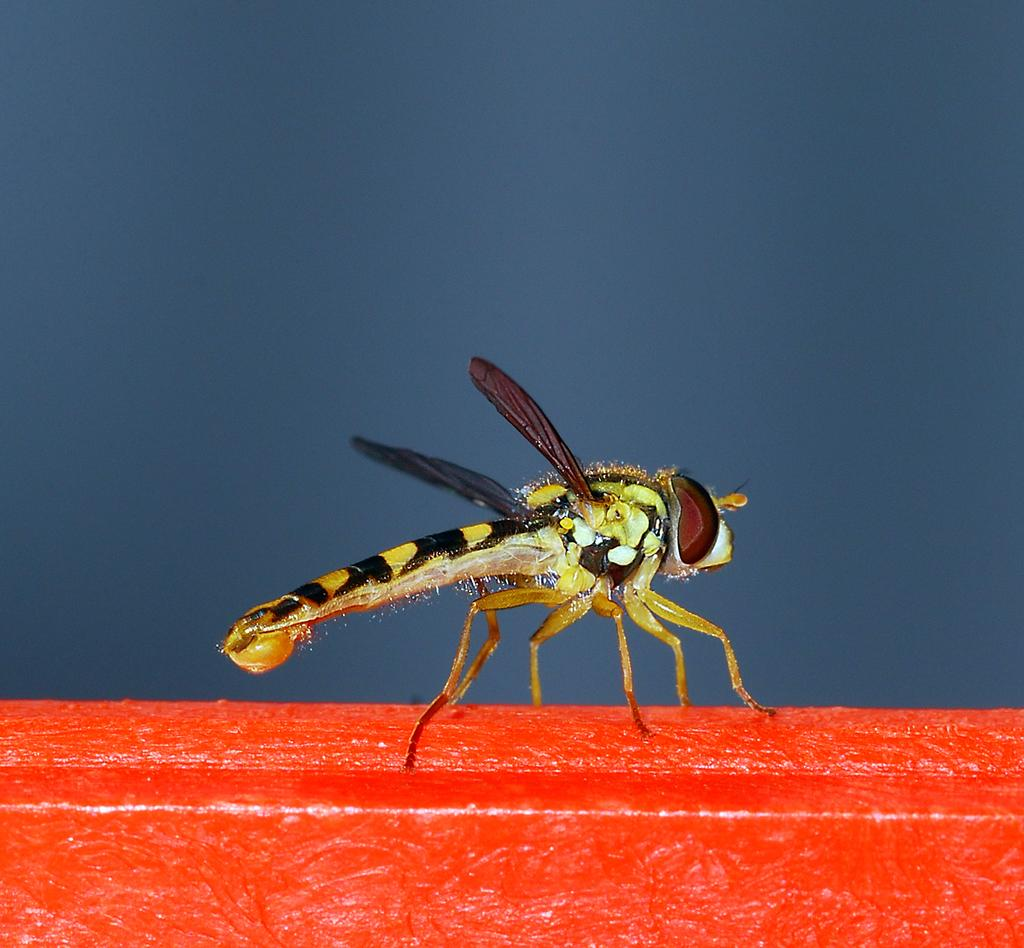What type of creature can be seen in the image? There is an insect in the image. What is the insect standing on? The insect is on a red color platform. What type of clam is visible in the image? There is no clam present in the image; it features an insect on a red color platform. What season is depicted in the image? The image does not depict a specific season, as there are no seasonal cues present. 